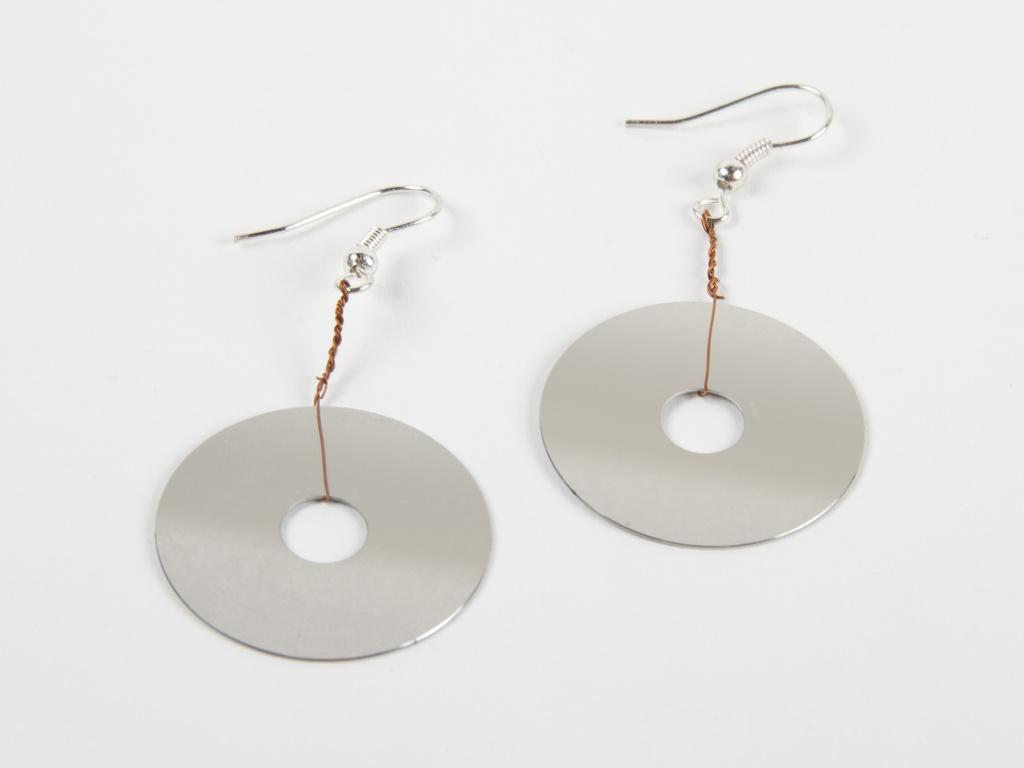What type of accessory is present in the image? There is a pair of earrings in the image. Can you describe the earrings in more detail? Unfortunately, the image does not provide enough detail to describe the earrings further. How many boys are affected by the earthquake in the image? There is no earthquake or boys present in the image; it only features a pair of earrings. 